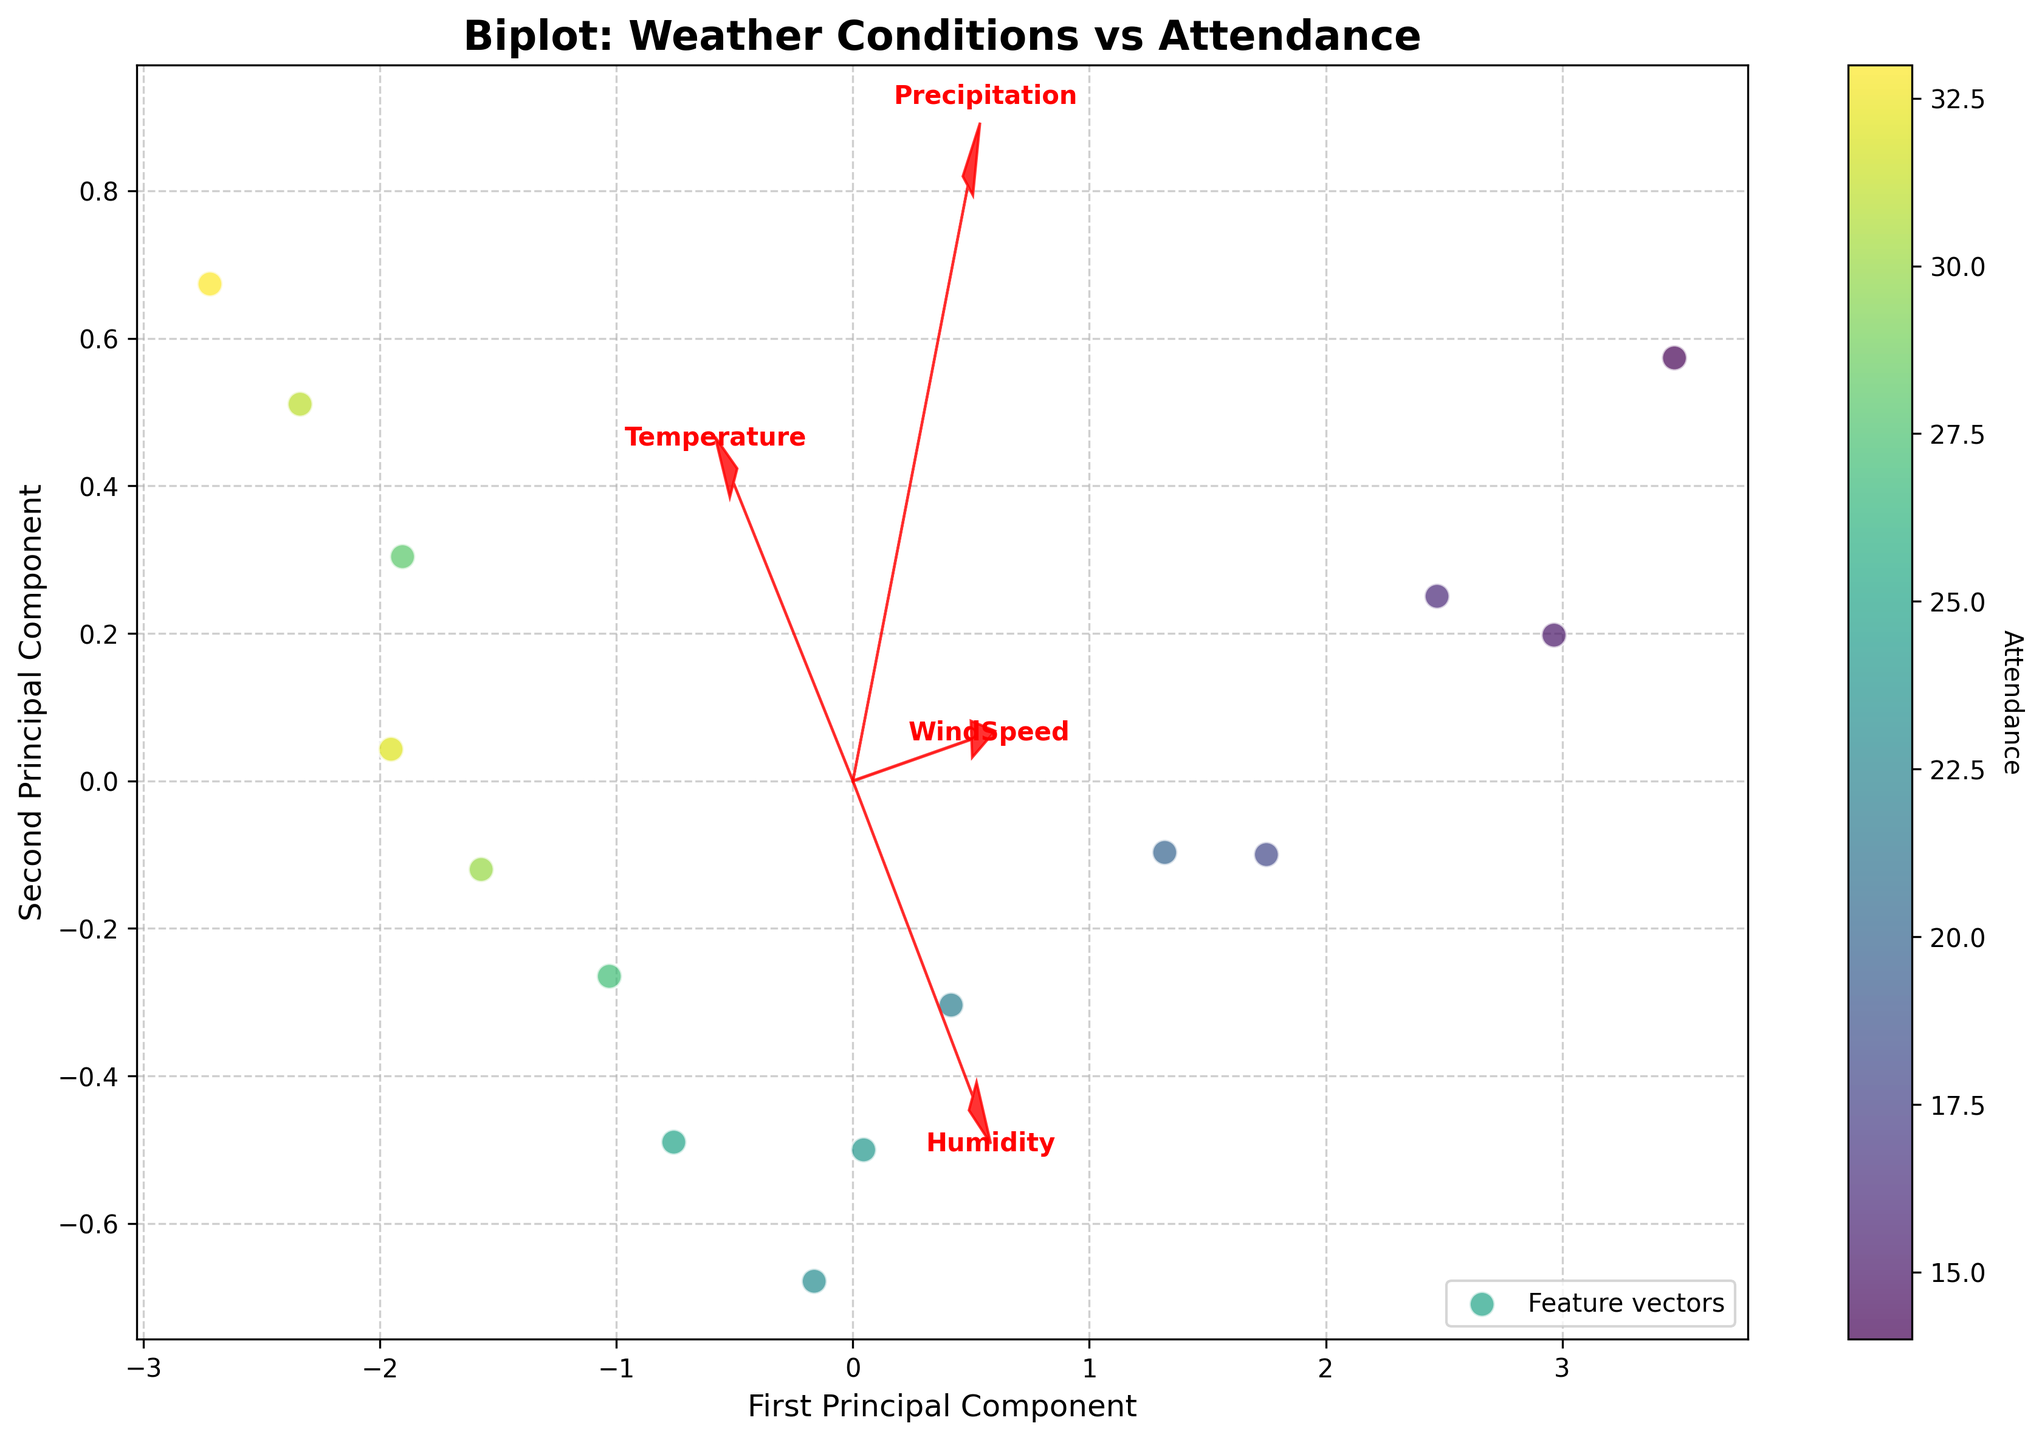What is the title of the figure? The title of the figure is normally positioned at the top, prominently labeled.
Answer: Biplot: Weather Conditions vs Attendance How many data points are shown in the plot? Data points are represented by the individual scatter points in the plot. You can count each dot to determine the number of data points.
Answer: 15 Which weather condition is represented by the arrow pointing the furthest to the right? Examine the direction and length of each arrow. The arrow pointing furthest to the right corresponds to the feature whose x-component is largest.
Answer: Temperature Which principal component (First or Second) has a greater influence of WindSpeed? Look at the arrows and see which principal component has a larger projection for WindSpeed. Whichever axis (PC1 or PC2) has a longer projection length for WindSpeed indicates its greater influence.
Answer: Second Principal Component Which feature seems to align most closely with high Attendance rates based on color? Notice the color gradient representing Attendance rates and see which feature's arrow points in the direction where high Attendance colors (darker shades) are clustered.
Answer: Temperature How does Precipitation affect Attendance based on the biplot? Observe the direction of the Precipitation arrow and the color gradient. If the arrow points towards lower Attendance colors, it suggests a negative relationship.
Answer: Negatively Which weather condition shows the least alignment with both principal components? Check which feature's arrow has the shortest length, as it indicates the least representation in both components.
Answer: Humidity Are there more data points with Attendance above 25 or below 25? Count the number of points associated with colors representing Attendance values above 25 and those below 25.
Answer: Above 25 Which weather condition has similar influence on both the First and Second Principal Components? Search for arrows that have almost equal projections on both principal components (neither strictly horizontal nor vertical).
Answer: WindSpeed Comparing Temperature and Humidity, which feature shows a stronger correlation with Attendance? Notice the direction in which higher Attendance rates (colors) align. The feature arrow pointing toward higher Attendance colors demonstrates a stronger correlation.
Answer: Temperature 